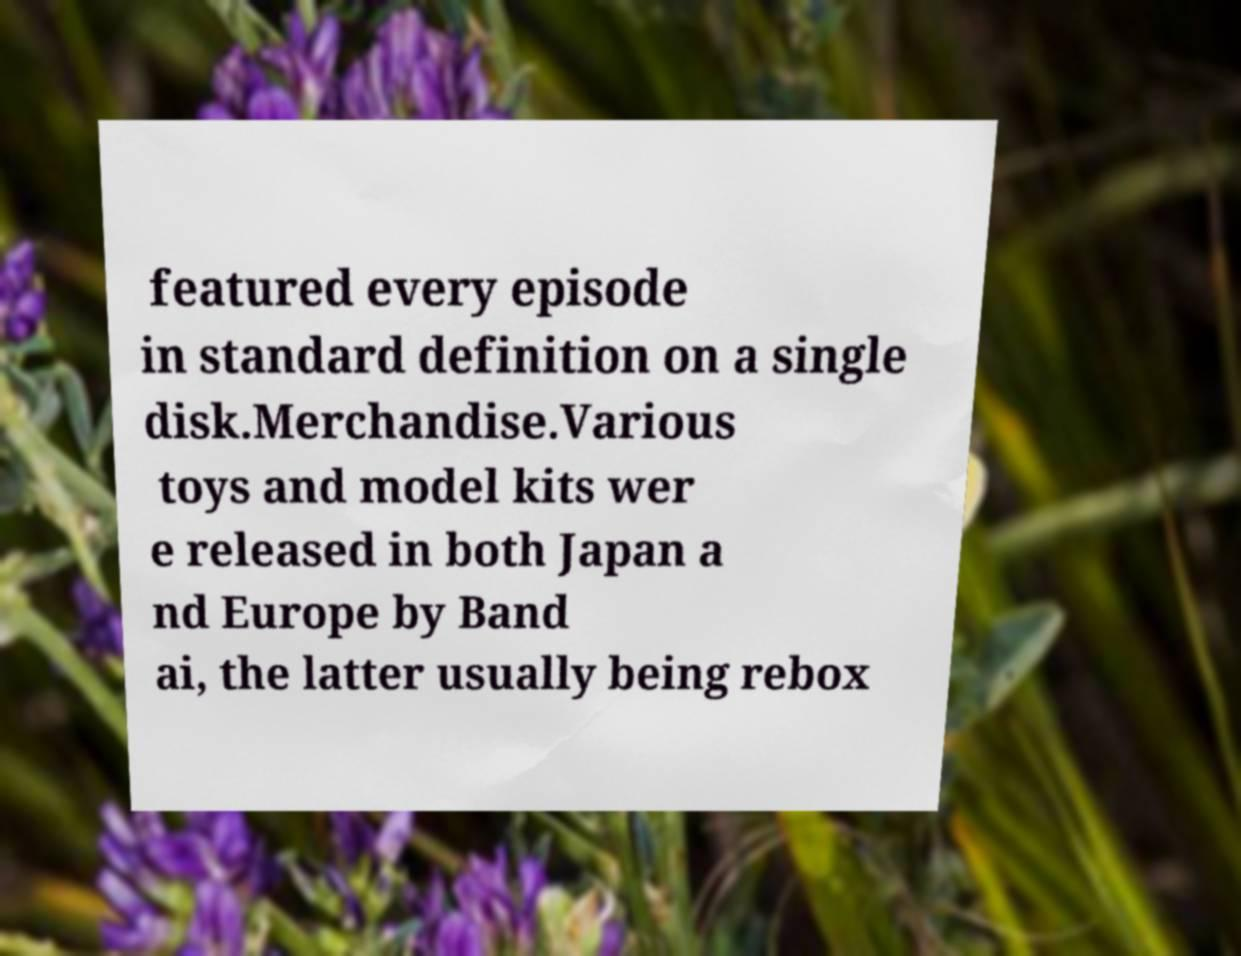I need the written content from this picture converted into text. Can you do that? featured every episode in standard definition on a single disk.Merchandise.Various toys and model kits wer e released in both Japan a nd Europe by Band ai, the latter usually being rebox 